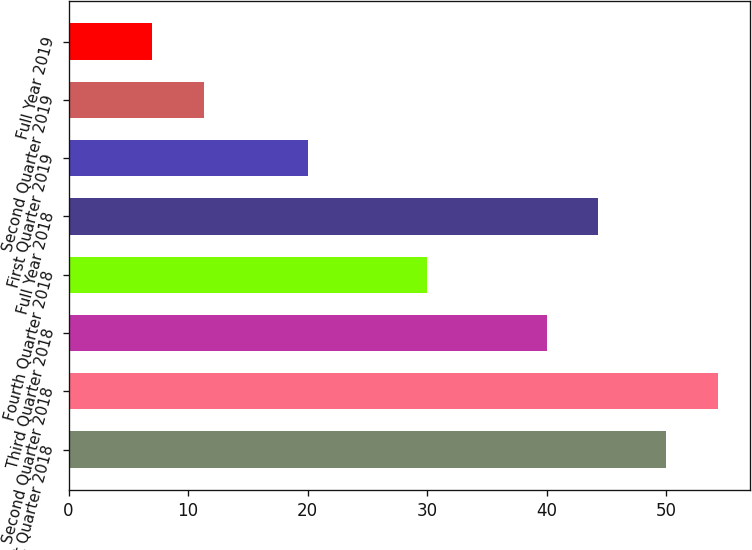<chart> <loc_0><loc_0><loc_500><loc_500><bar_chart><fcel>First Quarter 2018<fcel>Second Quarter 2018<fcel>Third Quarter 2018<fcel>Fourth Quarter 2018<fcel>Full Year 2018<fcel>First Quarter 2019<fcel>Second Quarter 2019<fcel>Full Year 2019<nl><fcel>50<fcel>54.3<fcel>40<fcel>30<fcel>44.3<fcel>20<fcel>11.3<fcel>7<nl></chart> 